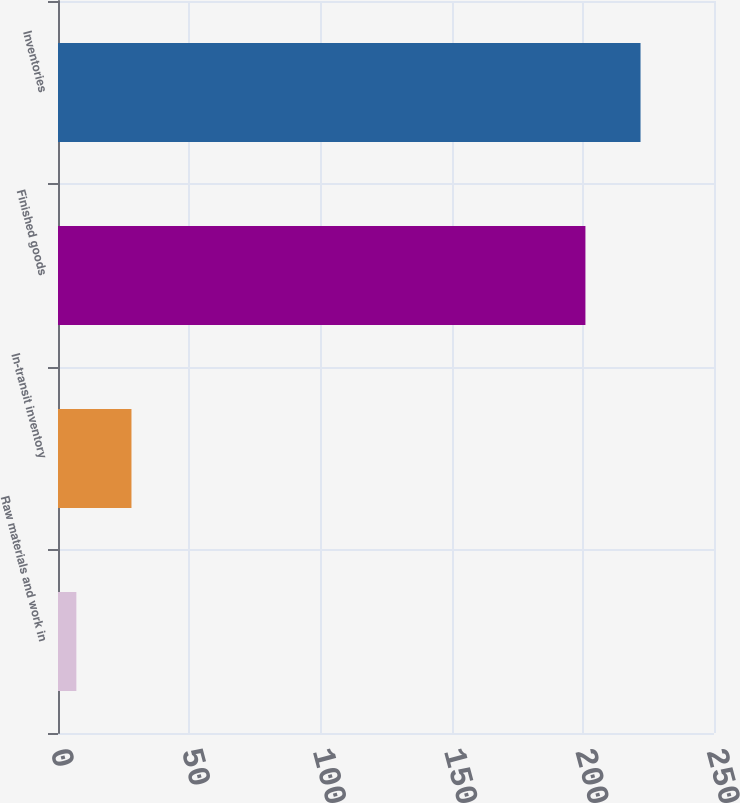<chart> <loc_0><loc_0><loc_500><loc_500><bar_chart><fcel>Raw materials and work in<fcel>In-transit inventory<fcel>Finished goods<fcel>Inventories<nl><fcel>7<fcel>28<fcel>201<fcel>222<nl></chart> 